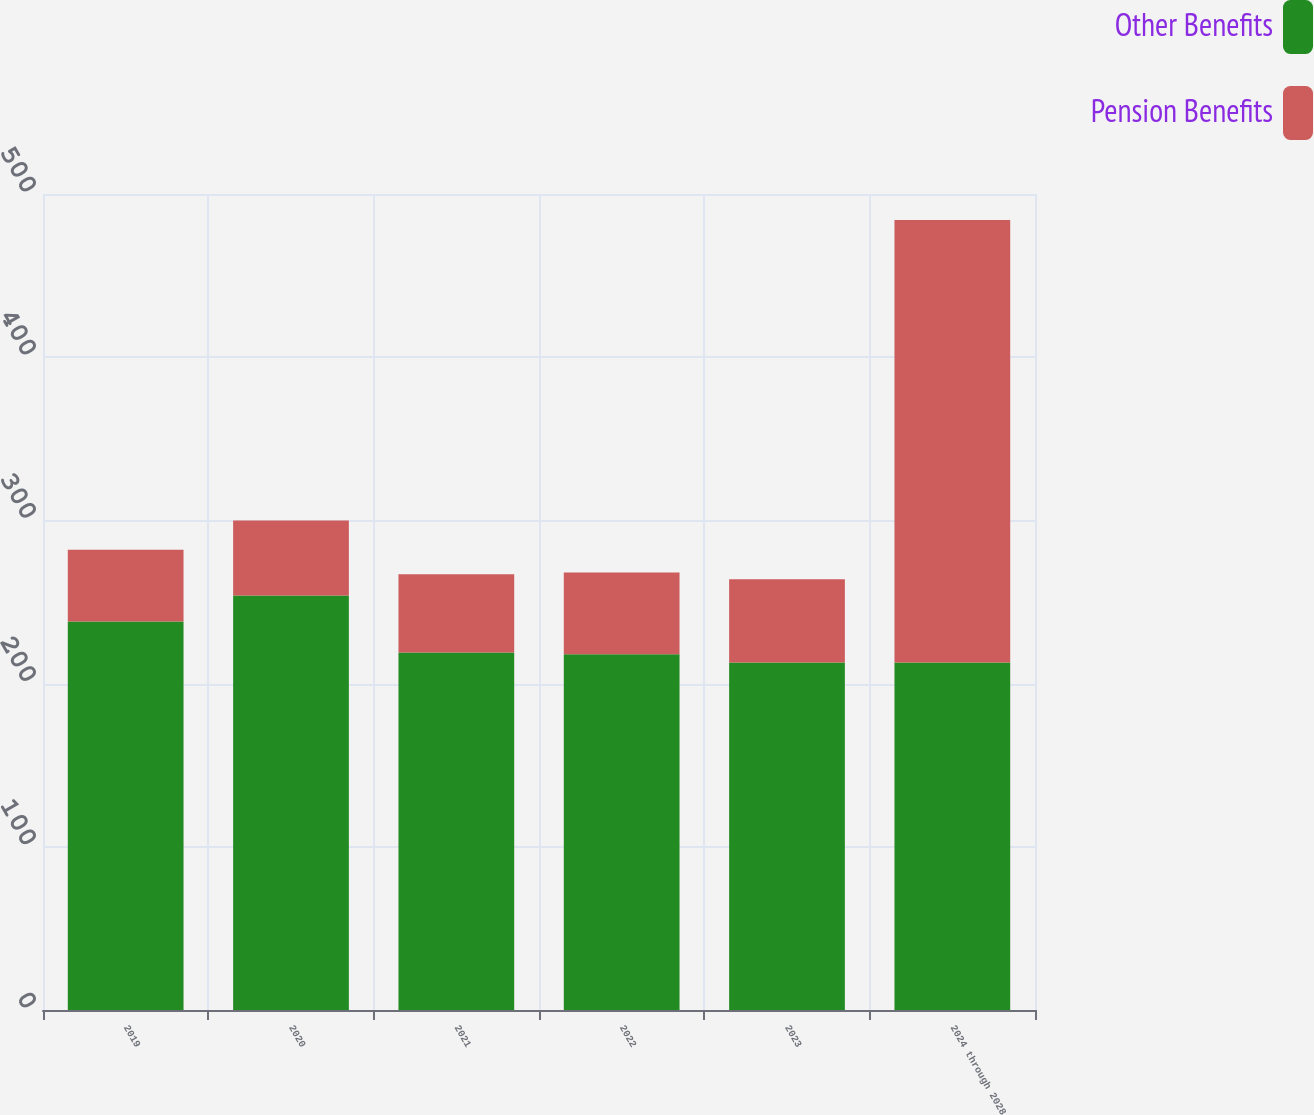<chart> <loc_0><loc_0><loc_500><loc_500><stacked_bar_chart><ecel><fcel>2019<fcel>2020<fcel>2021<fcel>2022<fcel>2023<fcel>2024 through 2028<nl><fcel>Other Benefits<fcel>238<fcel>254<fcel>219<fcel>218<fcel>213<fcel>213<nl><fcel>Pension Benefits<fcel>44<fcel>46<fcel>48<fcel>50<fcel>51<fcel>271<nl></chart> 